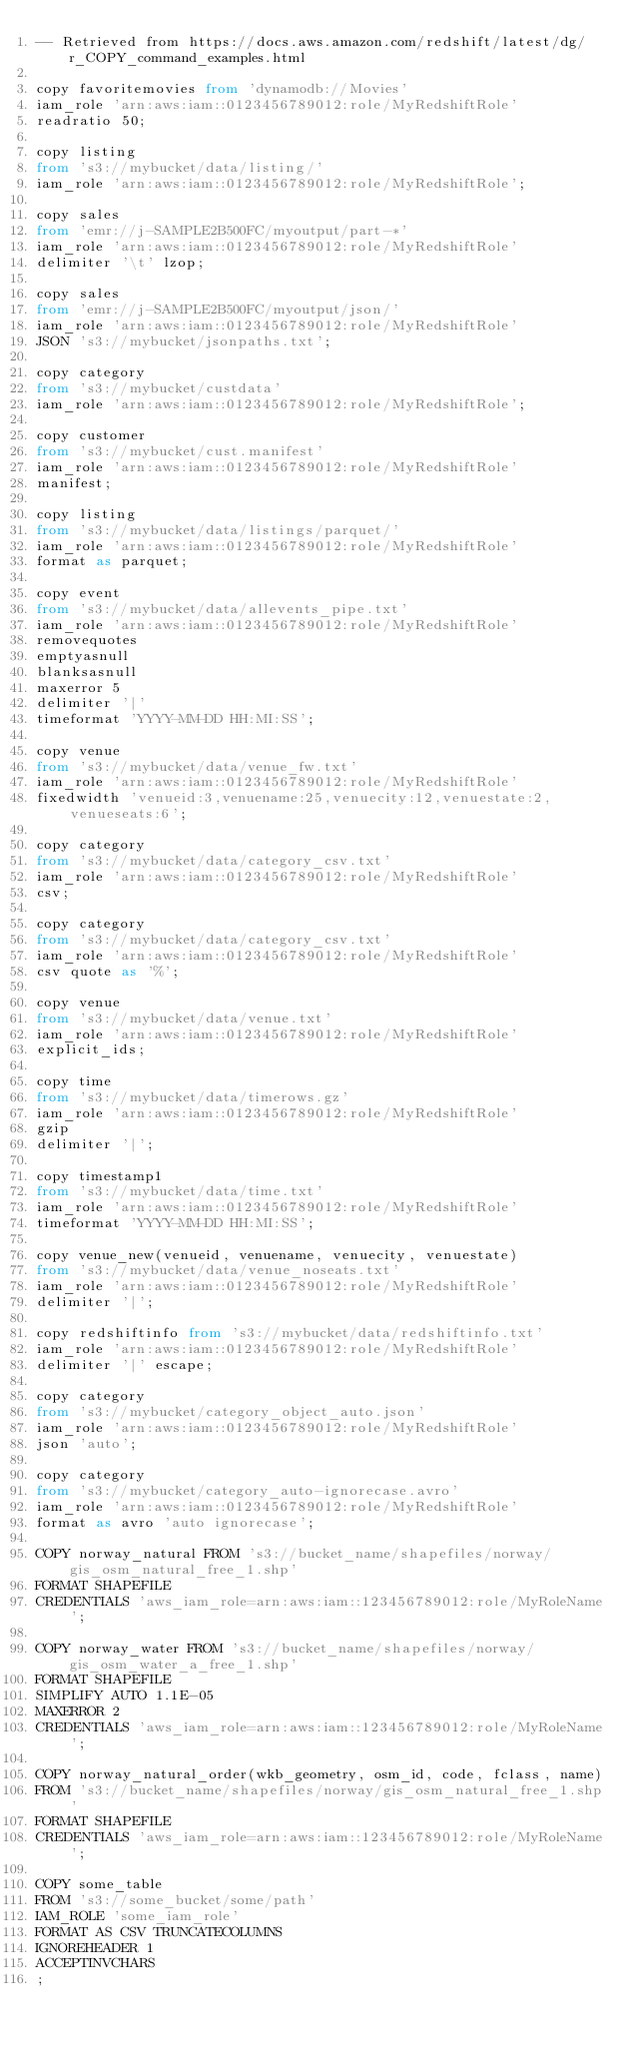<code> <loc_0><loc_0><loc_500><loc_500><_SQL_>-- Retrieved from https://docs.aws.amazon.com/redshift/latest/dg/r_COPY_command_examples.html

copy favoritemovies from 'dynamodb://Movies'
iam_role 'arn:aws:iam::0123456789012:role/MyRedshiftRole'
readratio 50;

copy listing
from 's3://mybucket/data/listing/'
iam_role 'arn:aws:iam::0123456789012:role/MyRedshiftRole';

copy sales
from 'emr://j-SAMPLE2B500FC/myoutput/part-*'
iam_role 'arn:aws:iam::0123456789012:role/MyRedshiftRole'
delimiter '\t' lzop;

copy sales
from 'emr://j-SAMPLE2B500FC/myoutput/json/'
iam_role 'arn:aws:iam::0123456789012:role/MyRedshiftRole'
JSON 's3://mybucket/jsonpaths.txt';

copy category
from 's3://mybucket/custdata'
iam_role 'arn:aws:iam::0123456789012:role/MyRedshiftRole';

copy customer
from 's3://mybucket/cust.manifest'
iam_role 'arn:aws:iam::0123456789012:role/MyRedshiftRole'
manifest;

copy listing
from 's3://mybucket/data/listings/parquet/'
iam_role 'arn:aws:iam::0123456789012:role/MyRedshiftRole'
format as parquet;

copy event
from 's3://mybucket/data/allevents_pipe.txt'
iam_role 'arn:aws:iam::0123456789012:role/MyRedshiftRole'
removequotes
emptyasnull
blanksasnull
maxerror 5
delimiter '|'
timeformat 'YYYY-MM-DD HH:MI:SS';

copy venue
from 's3://mybucket/data/venue_fw.txt'
iam_role 'arn:aws:iam::0123456789012:role/MyRedshiftRole'
fixedwidth 'venueid:3,venuename:25,venuecity:12,venuestate:2,venueseats:6';

copy category
from 's3://mybucket/data/category_csv.txt'
iam_role 'arn:aws:iam::0123456789012:role/MyRedshiftRole'
csv;

copy category
from 's3://mybucket/data/category_csv.txt'
iam_role 'arn:aws:iam::0123456789012:role/MyRedshiftRole'
csv quote as '%';

copy venue
from 's3://mybucket/data/venue.txt'
iam_role 'arn:aws:iam::0123456789012:role/MyRedshiftRole'
explicit_ids;

copy time
from 's3://mybucket/data/timerows.gz'
iam_role 'arn:aws:iam::0123456789012:role/MyRedshiftRole'
gzip
delimiter '|';

copy timestamp1
from 's3://mybucket/data/time.txt'
iam_role 'arn:aws:iam::0123456789012:role/MyRedshiftRole'
timeformat 'YYYY-MM-DD HH:MI:SS';

copy venue_new(venueid, venuename, venuecity, venuestate)
from 's3://mybucket/data/venue_noseats.txt'
iam_role 'arn:aws:iam::0123456789012:role/MyRedshiftRole'
delimiter '|';

copy redshiftinfo from 's3://mybucket/data/redshiftinfo.txt'
iam_role 'arn:aws:iam::0123456789012:role/MyRedshiftRole'
delimiter '|' escape;

copy category
from 's3://mybucket/category_object_auto.json'
iam_role 'arn:aws:iam::0123456789012:role/MyRedshiftRole'
json 'auto';

copy category
from 's3://mybucket/category_auto-ignorecase.avro'
iam_role 'arn:aws:iam::0123456789012:role/MyRedshiftRole'
format as avro 'auto ignorecase';

COPY norway_natural FROM 's3://bucket_name/shapefiles/norway/gis_osm_natural_free_1.shp'
FORMAT SHAPEFILE
CREDENTIALS 'aws_iam_role=arn:aws:iam::123456789012:role/MyRoleName';

COPY norway_water FROM 's3://bucket_name/shapefiles/norway/gis_osm_water_a_free_1.shp'
FORMAT SHAPEFILE
SIMPLIFY AUTO 1.1E-05
MAXERROR 2
CREDENTIALS 'aws_iam_role=arn:aws:iam::123456789012:role/MyRoleName';

COPY norway_natural_order(wkb_geometry, osm_id, code, fclass, name)
FROM 's3://bucket_name/shapefiles/norway/gis_osm_natural_free_1.shp'
FORMAT SHAPEFILE
CREDENTIALS 'aws_iam_role=arn:aws:iam::123456789012:role/MyRoleName';

COPY some_table
FROM 's3://some_bucket/some/path'
IAM_ROLE 'some_iam_role'
FORMAT AS CSV TRUNCATECOLUMNS
IGNOREHEADER 1
ACCEPTINVCHARS
;
</code> 